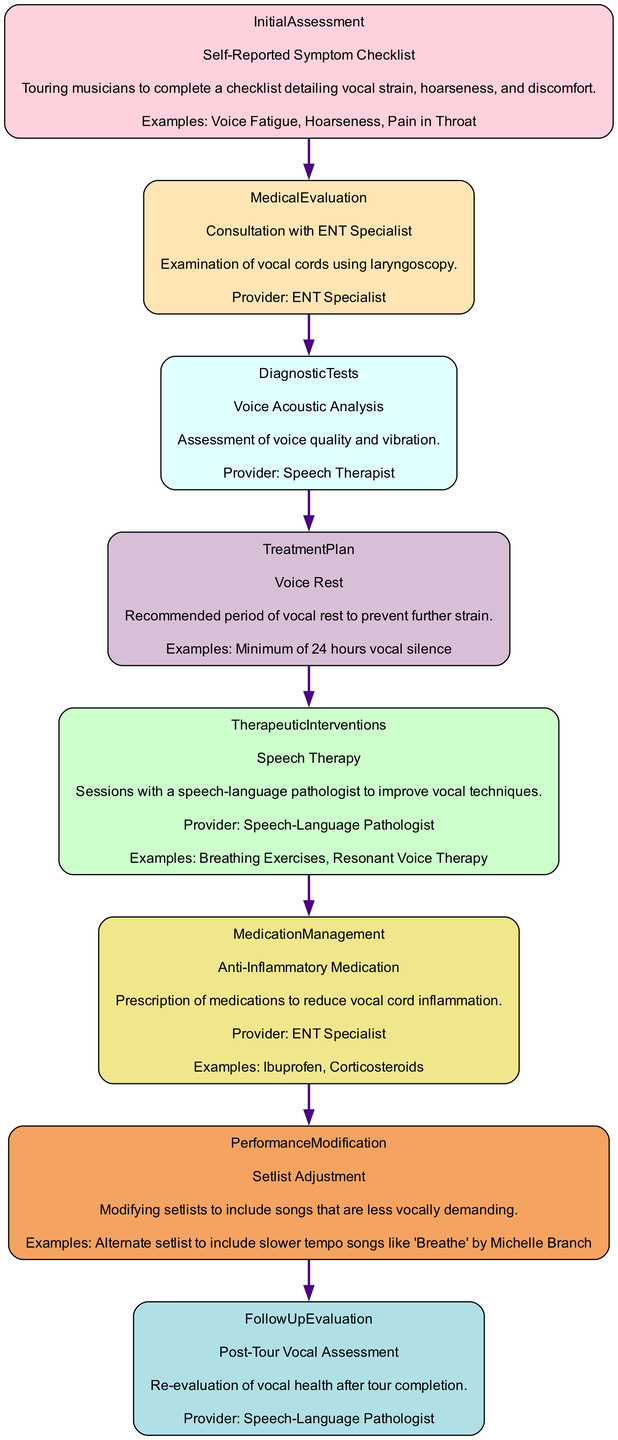What is the first step in the Initial Assessment? The first step is "Self-Reported Symptom Checklist." This is derived directly from the "InitialAssessment" section of the diagram.
Answer: Self-Reported Symptom Checklist Who provides the Voice Acoustic Analysis? The provider for this assessment is the "Speech Therapist," which can be found in the "DiagnosticTests" section.
Answer: Speech Therapist What type of medication is prescribed in Medication Management? In Medication Management, "Anti-Inflammatory Medication" is prescribed according to the details provided in that node.
Answer: Anti-Inflammatory Medication What is recommended in the Treatment Plan? The recommended action in the Treatment Plan is "Voice Rest," as specified in the related section of the diagram.
Answer: Voice Rest How many therapeutic interventions are listed in the diagram? There is one therapeutic intervention listed: "Speech Therapy." This is identified in the "TherapeuticInterventions" section.
Answer: 1 What does the Performance Modification step involve? The Performance Modification step involves adjusting the setlist to include songs that are less vocally demanding, which is stated clearly in that node.
Answer: Setlist Adjustment What is the purpose of the Follow-Up Evaluation? The purpose of the Follow-Up Evaluation is to conduct a "Post-Tour Vocal Assessment," which aims to re-evaluate vocal health after the tour.
Answer: Post-Tour Vocal Assessment Which step directly follows "Medical Evaluation"? The step that follows "Medical Evaluation" is "Diagnostic Tests," which is the next node connected in the diagram.
Answer: Diagnostic Tests What is an example of speech therapy listed in the Therapeutic Interventions? An example of speech therapy listed is "Breathing Exercises," taken from the "TherapeuticInterventions" section.
Answer: Breathing Exercises 